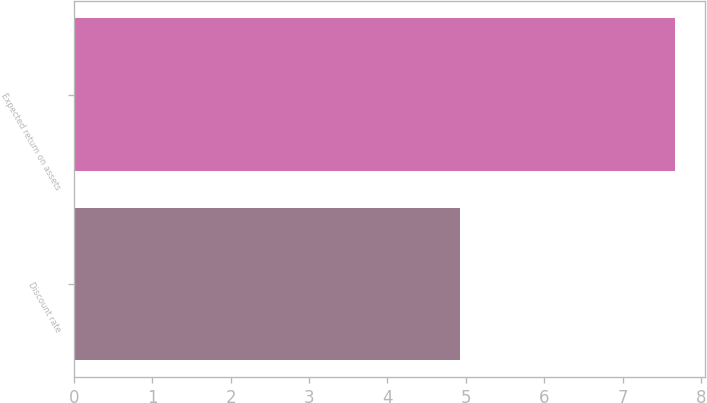<chart> <loc_0><loc_0><loc_500><loc_500><bar_chart><fcel>Discount rate<fcel>Expected return on assets<nl><fcel>4.93<fcel>7.67<nl></chart> 